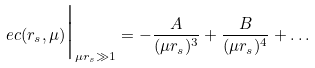Convert formula to latex. <formula><loc_0><loc_0><loc_500><loc_500>\ e c ( r _ { s } , \mu ) \Big | _ { \mu r _ { s } \gg 1 } = - \frac { A } { ( \mu r _ { s } ) ^ { 3 } } + \frac { B } { ( \mu r _ { s } ) ^ { 4 } } + \dots</formula> 